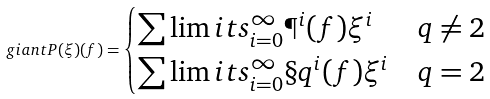<formula> <loc_0><loc_0><loc_500><loc_500>\ g i a n t P ( \xi ) ( f ) = \begin{cases} \sum \lim i t s _ { i = 0 } ^ { \infty } \P ^ { i } ( f ) \xi ^ { i } & q \neq 2 \\ \sum \lim i t s _ { i = 0 } ^ { \infty } \S q ^ { i } ( f ) \xi ^ { i } & q = 2 \end{cases}</formula> 